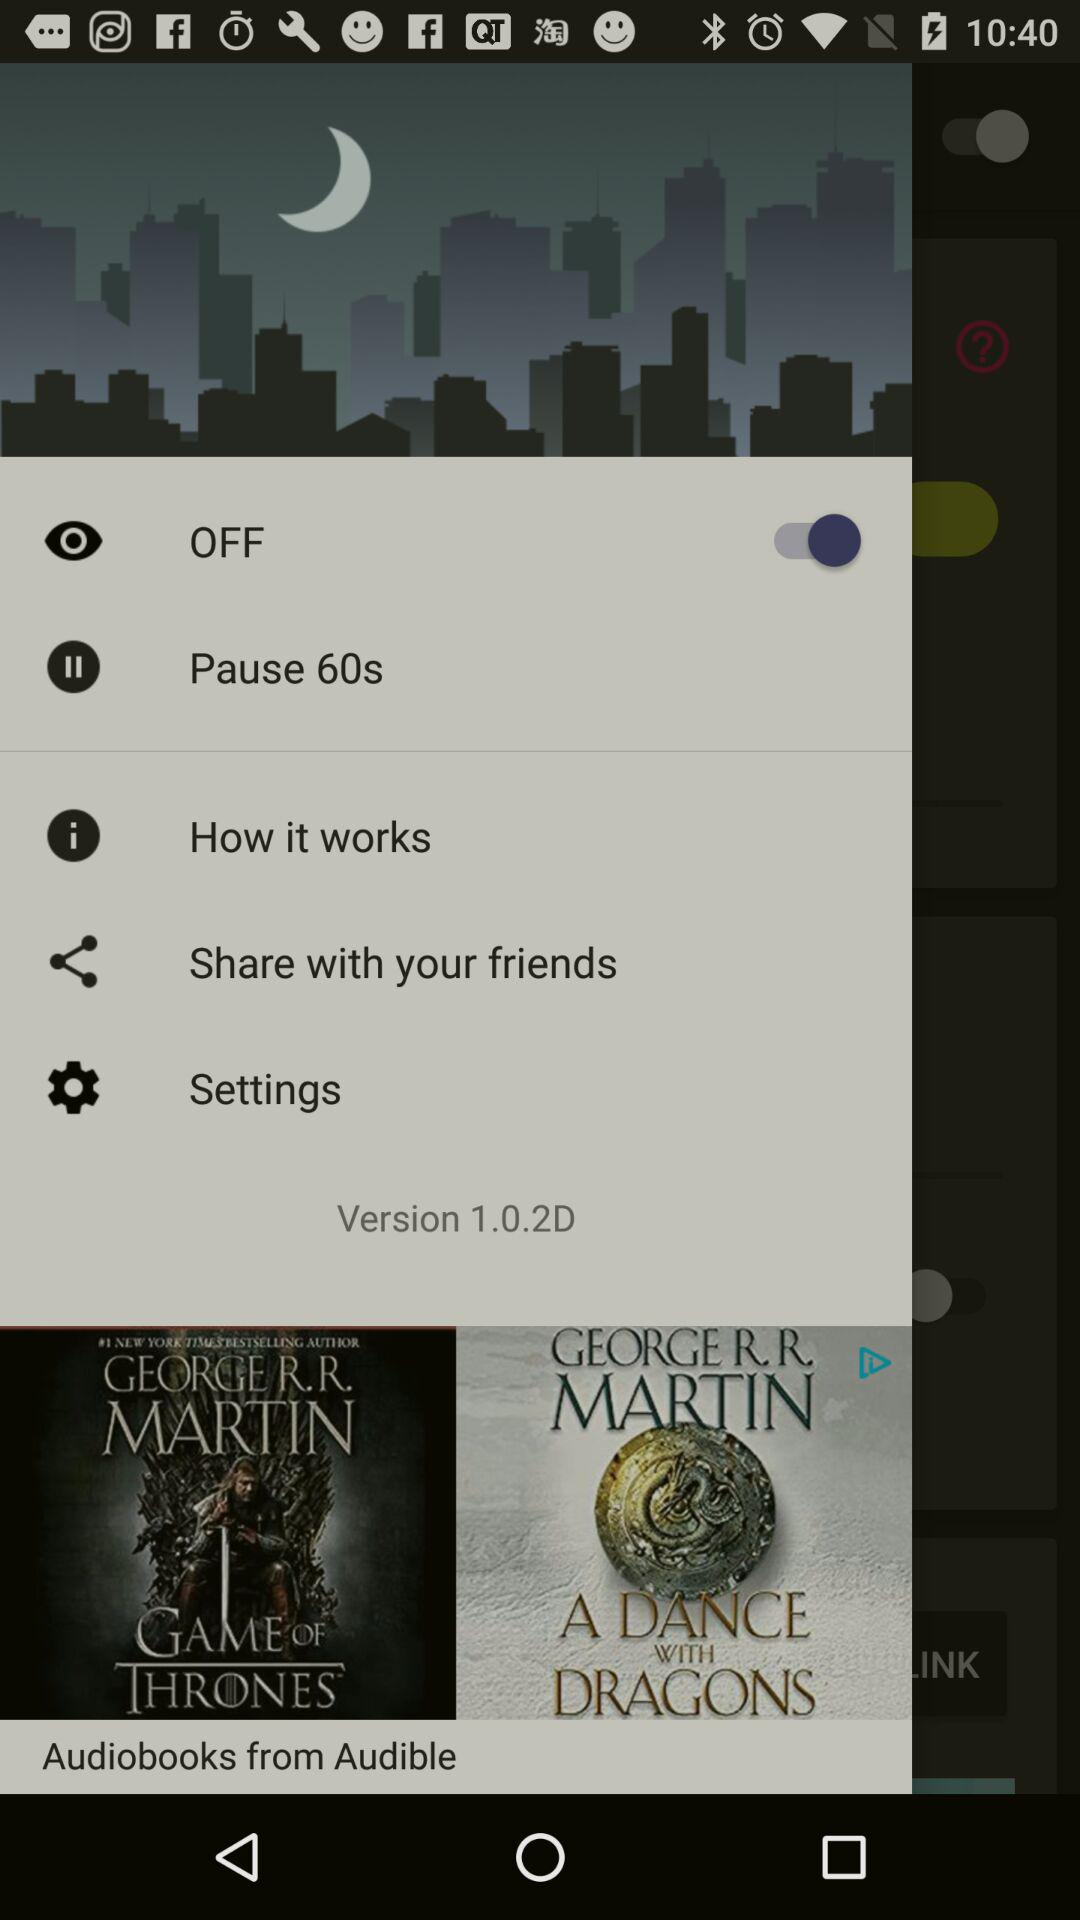What is the version? The version is 1.0.2D. 